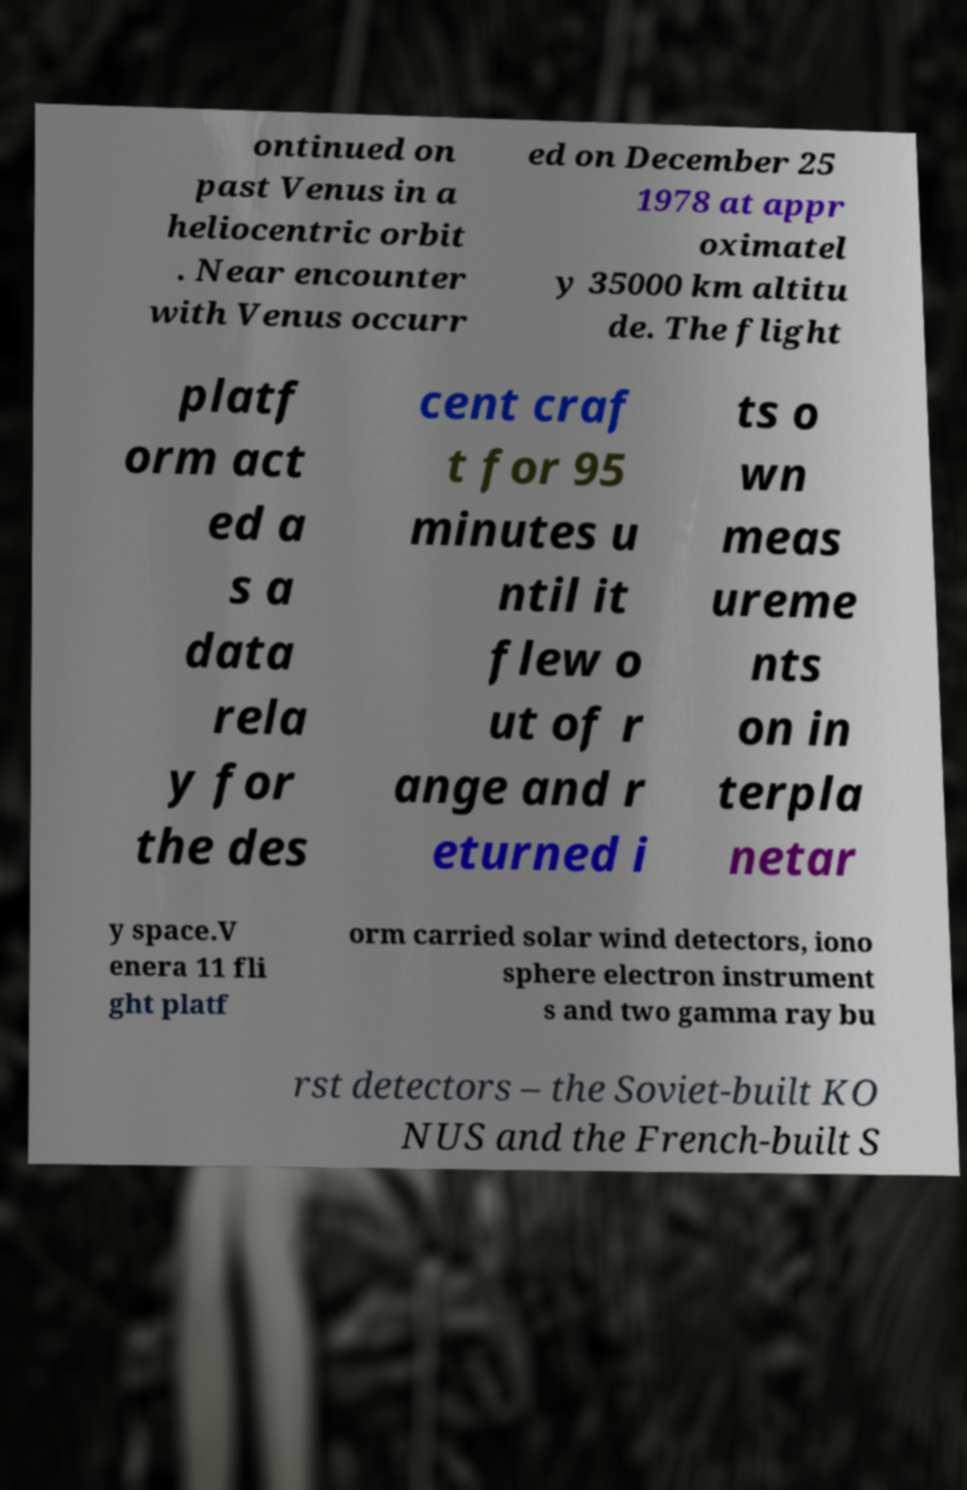Could you extract and type out the text from this image? ontinued on past Venus in a heliocentric orbit . Near encounter with Venus occurr ed on December 25 1978 at appr oximatel y 35000 km altitu de. The flight platf orm act ed a s a data rela y for the des cent craf t for 95 minutes u ntil it flew o ut of r ange and r eturned i ts o wn meas ureme nts on in terpla netar y space.V enera 11 fli ght platf orm carried solar wind detectors, iono sphere electron instrument s and two gamma ray bu rst detectors – the Soviet-built KO NUS and the French-built S 